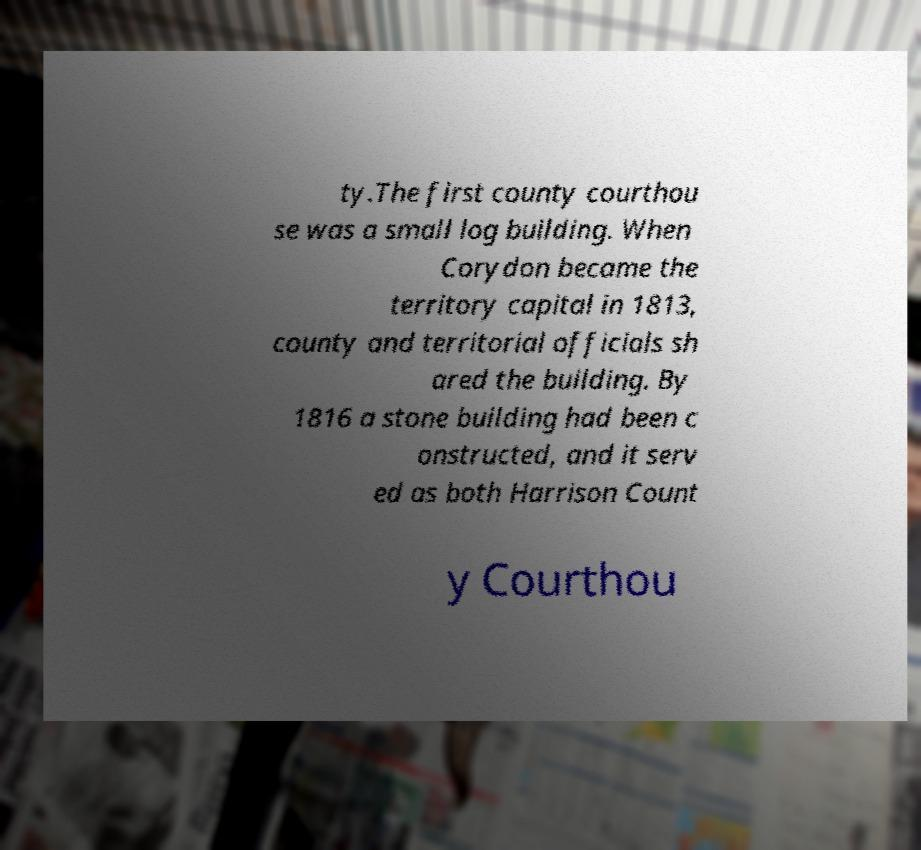For documentation purposes, I need the text within this image transcribed. Could you provide that? ty.The first county courthou se was a small log building. When Corydon became the territory capital in 1813, county and territorial officials sh ared the building. By 1816 a stone building had been c onstructed, and it serv ed as both Harrison Count y Courthou 